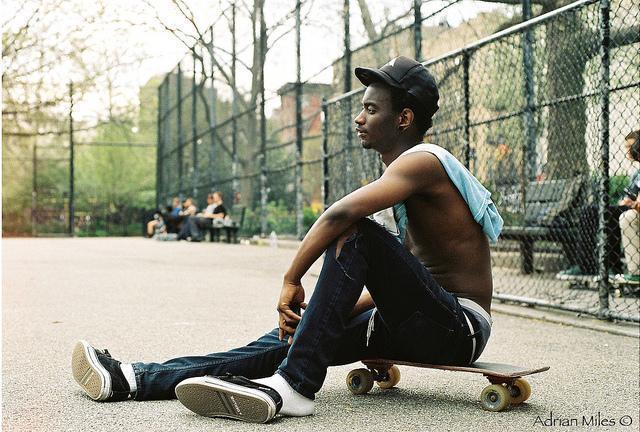How many people are there?
Give a very brief answer. 2. How many purple trains are there?
Give a very brief answer. 0. 